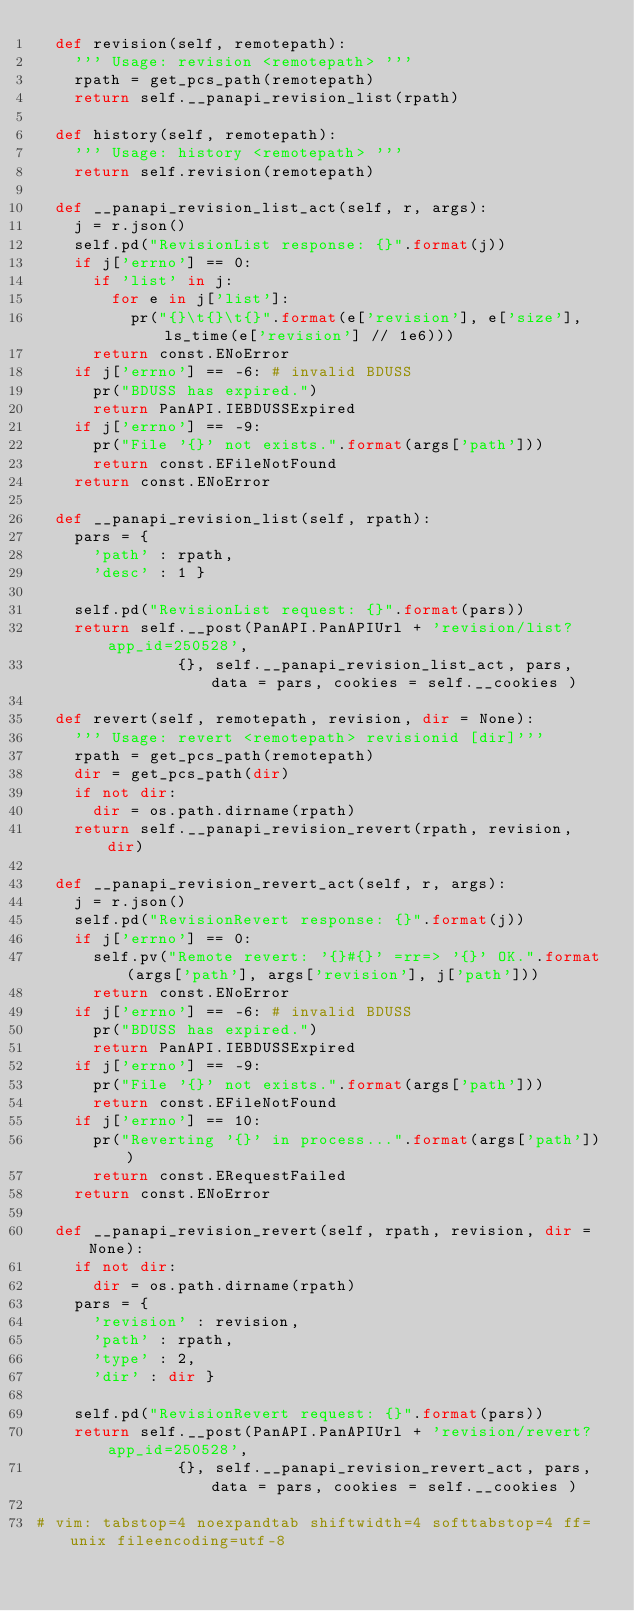<code> <loc_0><loc_0><loc_500><loc_500><_Python_>	def revision(self, remotepath):
		''' Usage: revision <remotepath> '''
		rpath = get_pcs_path(remotepath)
		return self.__panapi_revision_list(rpath)

	def history(self, remotepath):
		''' Usage: history <remotepath> '''
		return self.revision(remotepath)

	def __panapi_revision_list_act(self, r, args):
		j = r.json()
		self.pd("RevisionList response: {}".format(j))
		if j['errno'] == 0:
			if 'list' in j:
				for e in j['list']:
					pr("{}\t{}\t{}".format(e['revision'], e['size'], ls_time(e['revision'] // 1e6)))
			return const.ENoError
		if j['errno'] == -6: # invalid BDUSS
			pr("BDUSS has expired.")
			return PanAPI.IEBDUSSExpired
		if j['errno'] == -9:
			pr("File '{}' not exists.".format(args['path']))
			return const.EFileNotFound
		return const.ENoError

	def __panapi_revision_list(self, rpath):
		pars = {
			'path' : rpath,
			'desc' : 1 }

		self.pd("RevisionList request: {}".format(pars))
		return self.__post(PanAPI.PanAPIUrl + 'revision/list?app_id=250528',
						   {}, self.__panapi_revision_list_act, pars, data = pars, cookies = self.__cookies )

	def revert(self, remotepath, revision, dir = None):
		''' Usage: revert <remotepath> revisionid [dir]'''
		rpath = get_pcs_path(remotepath)
		dir = get_pcs_path(dir)
		if not dir:
			dir = os.path.dirname(rpath)
		return self.__panapi_revision_revert(rpath, revision, dir)

	def __panapi_revision_revert_act(self, r, args):
		j = r.json()
		self.pd("RevisionRevert response: {}".format(j))
		if j['errno'] == 0:
			self.pv("Remote revert: '{}#{}' =rr=> '{}' OK.".format(args['path'], args['revision'], j['path']))
			return const.ENoError
		if j['errno'] == -6: # invalid BDUSS
			pr("BDUSS has expired.")
			return PanAPI.IEBDUSSExpired
		if j['errno'] == -9:
			pr("File '{}' not exists.".format(args['path']))
			return const.EFileNotFound
		if j['errno'] == 10:
			pr("Reverting '{}' in process...".format(args['path']))
			return const.ERequestFailed
		return const.ENoError

	def __panapi_revision_revert(self, rpath, revision, dir = None):
		if not dir:
			dir = os.path.dirname(rpath)
		pars = {
			'revision' : revision,
			'path' : rpath,
			'type' : 2,
			'dir' : dir }

		self.pd("RevisionRevert request: {}".format(pars))
		return self.__post(PanAPI.PanAPIUrl + 'revision/revert?app_id=250528',
						   {}, self.__panapi_revision_revert_act, pars, data = pars, cookies = self.__cookies )

# vim: tabstop=4 noexpandtab shiftwidth=4 softtabstop=4 ff=unix fileencoding=utf-8
</code> 